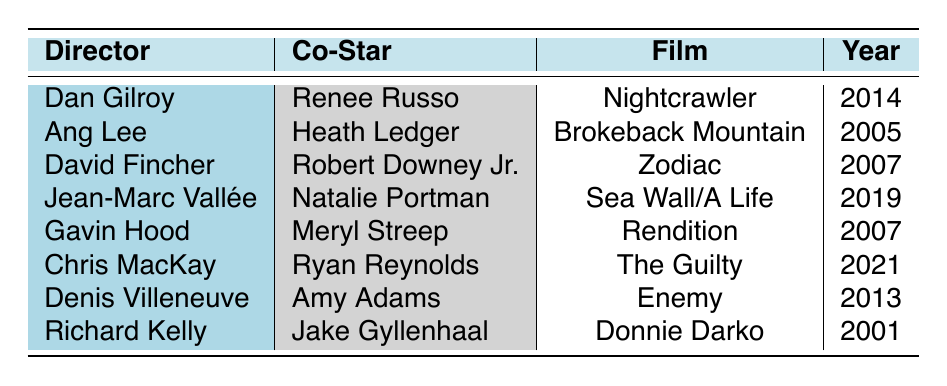What film did Jake Gyllenhaal collaborate on with Richard Kelly? The table lists the films directed by different directors. Looking at the row under Richard Kelly, it shows the film "Donnie Darko" which is the collaboration with Jake Gyllenhaal.
Answer: Donnie Darko Who was the co-star in "Brokeback Mountain"? The row for "Brokeback Mountain" under the director Ang Lee shows that the co-star was Heath Ledger.
Answer: Heath Ledger How many films did Jake Gyllenhaal work on with Denis Villeneuve? The table shows only one entry for the director Denis Villeneuve where he directed Jake Gyllenhaal in "Enemy."
Answer: 1 Did Jake Gyllenhaal act with Meryl Streep in any film? By checking the table, it can be seen that Jake Gyllenhaal did not act with Meryl Streep. The entry for Meryl Streep is with Gavin Hood, not Jake Gyllenhaal.
Answer: No Which director worked with Natalie Portman on a film featuring Jake Gyllenhaal? The table shows that Jean-Marc Vallée directed the film "Sea Wall/A Life" with Natalie Portman, but there is no connection with Jake Gyllenhaal in this entry. Therefore, no director worked with both.
Answer: None Count the number of films directed by Dan Gilroy listed in the table. There is only one entry for Dan Gilroy in the table, which is "Nightcrawler." Thus, the count of films directed by him is one.
Answer: 1 Is "Zodiac" from 2007 associated with David Fincher? Looking at the table, it is evident that "Zodiac," directed by David Fincher, is indeed from 2007, confirming the association.
Answer: Yes Which film features the collaboration between Jake Gyllenhaal and a co-star in 2014? In the table, the film "Nightcrawler" directed by Dan Gilroy features Gyllenhaal and his co-star Renee Russo in 2014.
Answer: Nightcrawler How many films from 2007 are listed in the table? The table shows two entries from 2007: "Zodiac" by David Fincher and "Rendition" by Gavin Hood. Therefore, the total count is two.
Answer: 2 